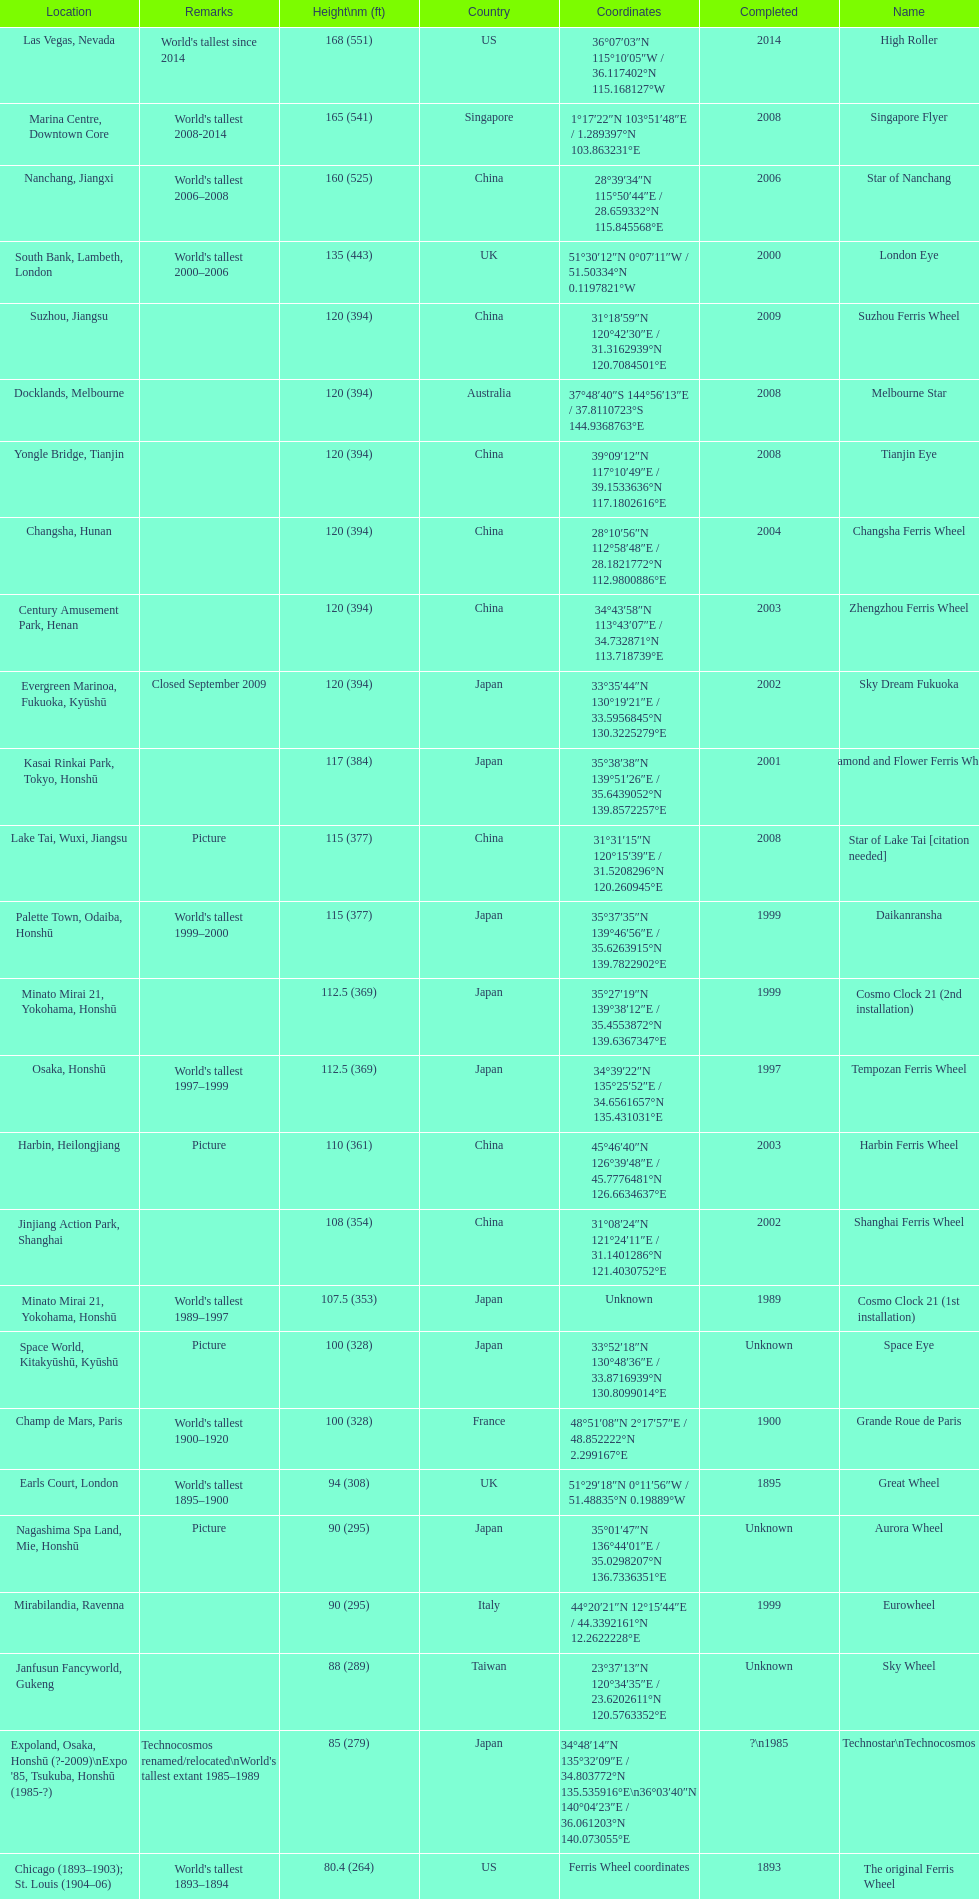How tall is the roller coaster star of nanchang? 165 (541). When was the roller coaster star of nanchang completed? 2008. What is the name of the oldest roller coaster? Star of Nanchang. 